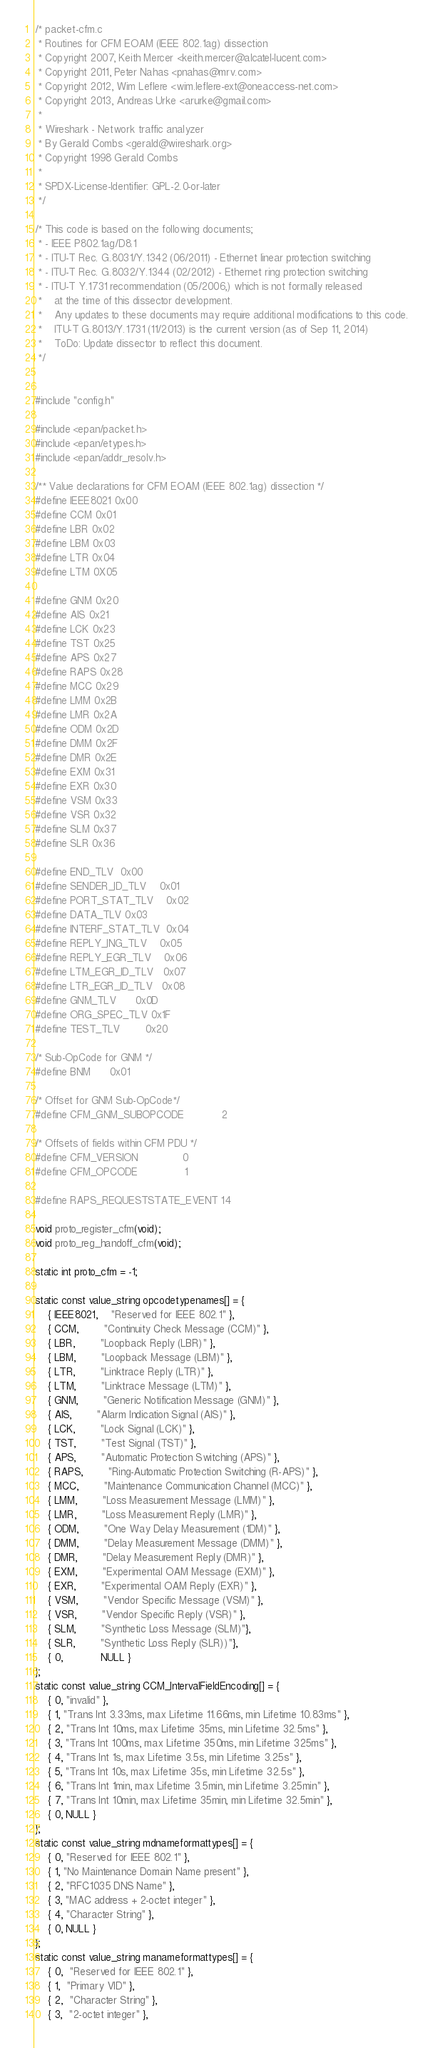<code> <loc_0><loc_0><loc_500><loc_500><_C_>/* packet-cfm.c
 * Routines for CFM EOAM (IEEE 802.1ag) dissection
 * Copyright 2007, Keith Mercer <keith.mercer@alcatel-lucent.com>
 * Copyright 2011, Peter Nahas <pnahas@mrv.com>
 * Copyright 2012, Wim Leflere <wim.leflere-ext@oneaccess-net.com>
 * Copyright 2013, Andreas Urke <arurke@gmail.com>
 *
 * Wireshark - Network traffic analyzer
 * By Gerald Combs <gerald@wireshark.org>
 * Copyright 1998 Gerald Combs
 *
 * SPDX-License-Identifier: GPL-2.0-or-later
 */

/* This code is based on the following documents;
 * - IEEE P802.1ag/D8.1
 * - ITU-T Rec. G.8031/Y.1342 (06/2011) - Ethernet linear protection switching
 * - ITU-T Rec. G.8032/Y.1344 (02/2012) - Ethernet ring protection switching
 * - ITU-T Y.1731 recommendation (05/2006,) which is not formally released
 *    at the time of this dissector development.
 *    Any updates to these documents may require additional modifications to this code.
 *    ITU-T G.8013/Y.1731 (11/2013) is the current version (as of Sep 11, 2014)
 *    ToDo: Update dissector to reflect this document.
 */


#include "config.h"

#include <epan/packet.h>
#include <epan/etypes.h>
#include <epan/addr_resolv.h>

/** Value declarations for CFM EOAM (IEEE 802.1ag) dissection */
#define IEEE8021 0x00
#define CCM 0x01
#define LBR 0x02
#define LBM 0x03
#define LTR 0x04
#define LTM 0X05

#define GNM 0x20
#define AIS 0x21
#define LCK 0x23
#define TST 0x25
#define APS 0x27
#define RAPS 0x28
#define MCC 0x29
#define LMM 0x2B
#define LMR 0x2A
#define ODM 0x2D
#define DMM 0x2F
#define DMR 0x2E
#define EXM 0x31
#define EXR 0x30
#define VSM 0x33
#define VSR 0x32
#define SLM 0x37
#define SLR 0x36

#define END_TLV 	0x00
#define SENDER_ID_TLV	0x01
#define PORT_STAT_TLV	0x02
#define DATA_TLV	0x03
#define INTERF_STAT_TLV	0x04
#define REPLY_ING_TLV	0x05
#define REPLY_EGR_TLV	0x06
#define LTM_EGR_ID_TLV	0x07
#define LTR_EGR_ID_TLV	0x08
#define GNM_TLV		0x0D
#define ORG_SPEC_TLV	0x1F
#define TEST_TLV        0x20

/* Sub-OpCode for GNM */
#define BNM		0x01

/* Offset for GNM Sub-OpCode*/
#define CFM_GNM_SUBOPCODE			2

/* Offsets of fields within CFM PDU */
#define CFM_VERSION				0
#define CFM_OPCODE				1

#define RAPS_REQUESTSTATE_EVENT 14

void proto_register_cfm(void);
void proto_reg_handoff_cfm(void);

static int proto_cfm = -1;

static const value_string opcodetypenames[] = {
	{ IEEE8021, 	"Reserved for IEEE 802.1" },
	{ CCM, 		"Continuity Check Message (CCM)" },
	{ LBR, 		"Loopback Reply (LBR)" },
	{ LBM, 		"Loopback Message (LBM)" },
	{ LTR, 		"Linktrace Reply (LTR)" },
	{ LTM, 		"Linktrace Message (LTM)" },
	{ GNM,		"Generic Notification Message (GNM)" },
	{ AIS,		"Alarm Indication Signal (AIS)" },
	{ LCK,		"Lock Signal (LCK)" },
	{ TST,		"Test Signal (TST)" },
	{ APS,		"Automatic Protection Switching (APS)" },
	{ RAPS,		"Ring-Automatic Protection Switching (R-APS)" },
	{ MCC,		"Maintenance Communication Channel (MCC)" },
	{ LMM,		"Loss Measurement Message (LMM)" },
	{ LMR,		"Loss Measurement Reply (LMR)" },
	{ ODM,		"One Way Delay Measurement (1DM)" },
	{ DMM,		"Delay Measurement Message (DMM)" },
	{ DMR,		"Delay Measurement Reply (DMR)" },
	{ EXM,		"Experimental OAM Message (EXM)" },
	{ EXR,		"Experimental OAM Reply (EXR)" },
	{ VSM,		"Vendor Specific Message (VSM)" },
	{ VSR,		"Vendor Specific Reply (VSR)" },
	{ SLM,		"Synthetic Loss Message (SLM)"},
	{ SLR,		"Synthetic Loss Reply (SLR))"},
	{ 0,            NULL }
};
static const value_string CCM_IntervalFieldEncoding[] = {
	{ 0, "invalid" },
	{ 1, "Trans Int 3.33ms, max Lifetime 11.66ms, min Lifetime 10.83ms" },
	{ 2, "Trans Int 10ms, max Lifetime 35ms, min Lifetime 32.5ms" },
	{ 3, "Trans Int 100ms, max Lifetime 350ms, min Lifetime 325ms" },
	{ 4, "Trans Int 1s, max Lifetime 3.5s, min Lifetime 3.25s" },
	{ 5, "Trans Int 10s, max Lifetime 35s, min Lifetime 32.5s" },
	{ 6, "Trans Int 1min, max Lifetime 3.5min, min Lifetime 3.25min" },
	{ 7, "Trans Int 10min, max Lifetime 35min, min Lifetime 32.5min" },
	{ 0, NULL }
};
static const value_string mdnameformattypes[] = {
	{ 0, "Reserved for IEEE 802.1" },
	{ 1, "No Maintenance Domain Name present" },
	{ 2, "RFC1035 DNS Name" },
	{ 3, "MAC address + 2-octet integer" },
	{ 4, "Character String" },
	{ 0, NULL }
};
static const value_string manameformattypes[] = {
	{ 0,  "Reserved for IEEE 802.1" },
	{ 1,  "Primary VID" },
	{ 2,  "Character String" },
	{ 3,  "2-octet integer" },</code> 